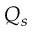<formula> <loc_0><loc_0><loc_500><loc_500>Q _ { s }</formula> 